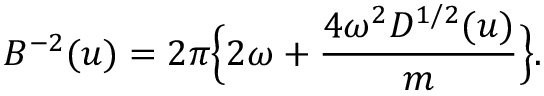Convert formula to latex. <formula><loc_0><loc_0><loc_500><loc_500>B ^ { - 2 } ( u ) = 2 \pi \left \{ 2 \omega + { \frac { 4 \omega ^ { 2 } D ^ { 1 / 2 } ( u ) } { m } } \right \} .</formula> 